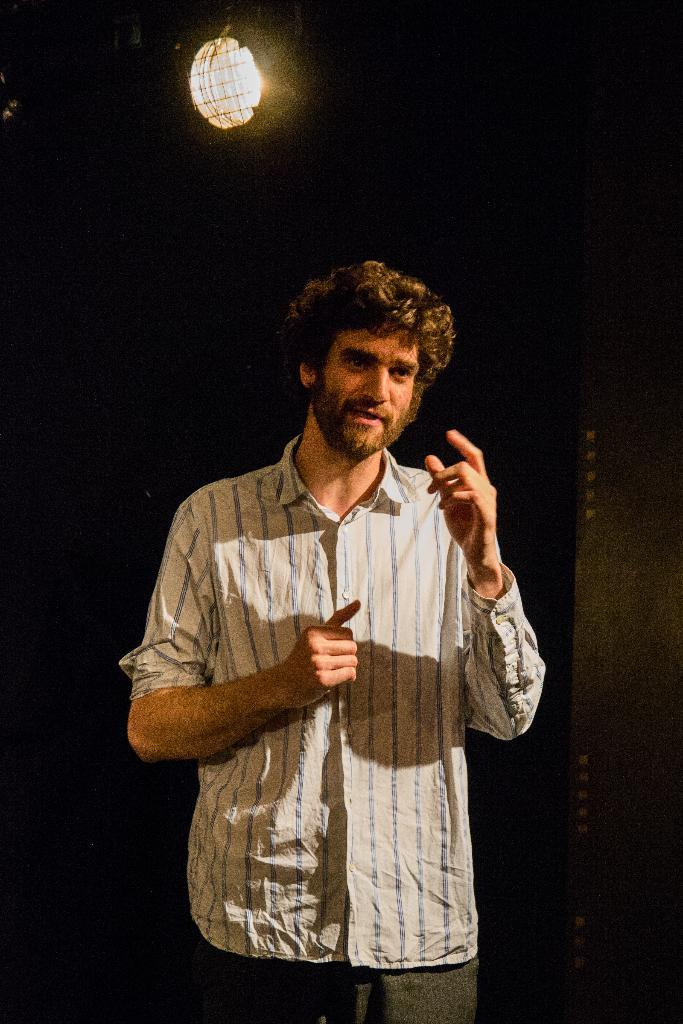What is the main subject of the image? There is a man standing in the image. What is the man doing in the image? The man is talking. How would you describe the background of the image? The background of the image is dark. Can you see any light in the background? Yes, there is light visible in the background. What type of art can be seen hanging on the wall in the image? There is no mention of any art or wall in the image; it only features a man standing and talking against a dark background with visible light. 